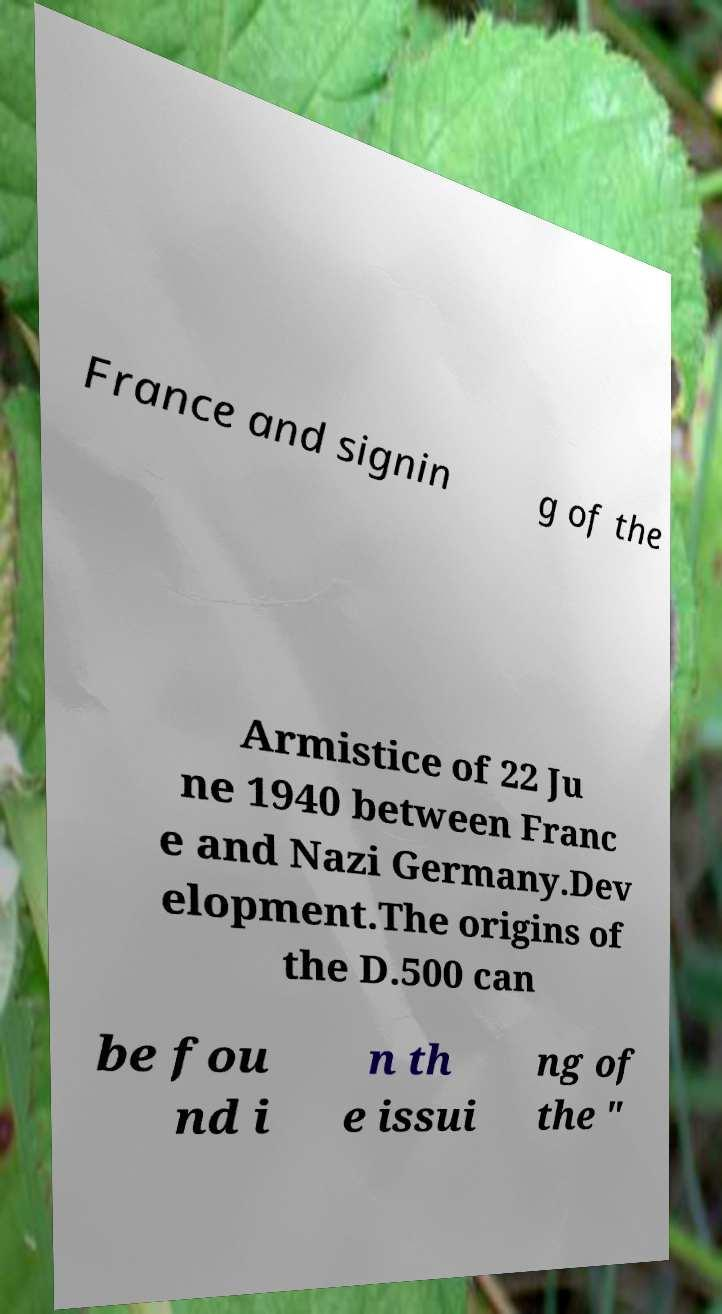For documentation purposes, I need the text within this image transcribed. Could you provide that? France and signin g of the Armistice of 22 Ju ne 1940 between Franc e and Nazi Germany.Dev elopment.The origins of the D.500 can be fou nd i n th e issui ng of the " 